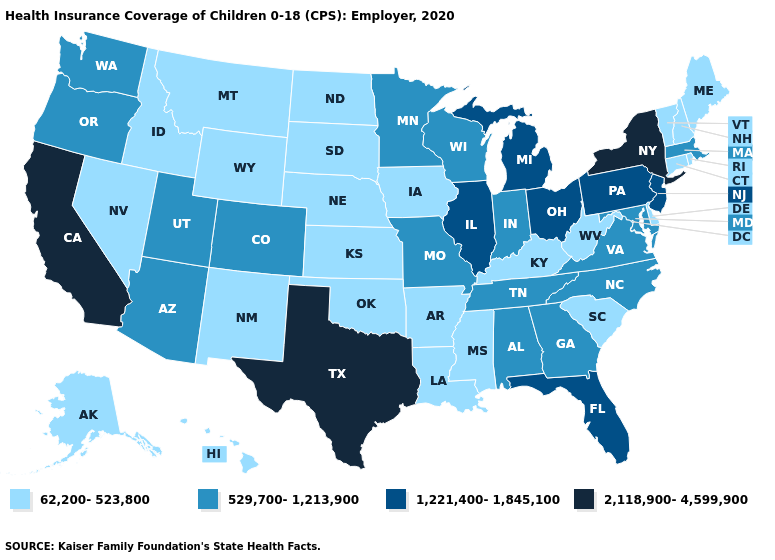What is the lowest value in the USA?
Write a very short answer. 62,200-523,800. Name the states that have a value in the range 62,200-523,800?
Short answer required. Alaska, Arkansas, Connecticut, Delaware, Hawaii, Idaho, Iowa, Kansas, Kentucky, Louisiana, Maine, Mississippi, Montana, Nebraska, Nevada, New Hampshire, New Mexico, North Dakota, Oklahoma, Rhode Island, South Carolina, South Dakota, Vermont, West Virginia, Wyoming. Does Texas have the highest value in the USA?
Answer briefly. Yes. What is the value of Wisconsin?
Keep it brief. 529,700-1,213,900. What is the highest value in the West ?
Concise answer only. 2,118,900-4,599,900. Which states have the lowest value in the USA?
Give a very brief answer. Alaska, Arkansas, Connecticut, Delaware, Hawaii, Idaho, Iowa, Kansas, Kentucky, Louisiana, Maine, Mississippi, Montana, Nebraska, Nevada, New Hampshire, New Mexico, North Dakota, Oklahoma, Rhode Island, South Carolina, South Dakota, Vermont, West Virginia, Wyoming. What is the lowest value in the South?
Write a very short answer. 62,200-523,800. Does Colorado have the lowest value in the USA?
Be succinct. No. Does North Dakota have the same value as New Hampshire?
Be succinct. Yes. Among the states that border Michigan , which have the lowest value?
Concise answer only. Indiana, Wisconsin. Does Hawaii have the lowest value in the USA?
Give a very brief answer. Yes. Among the states that border Ohio , does Michigan have the highest value?
Be succinct. Yes. Name the states that have a value in the range 529,700-1,213,900?
Short answer required. Alabama, Arizona, Colorado, Georgia, Indiana, Maryland, Massachusetts, Minnesota, Missouri, North Carolina, Oregon, Tennessee, Utah, Virginia, Washington, Wisconsin. Does Texas have the highest value in the USA?
Quick response, please. Yes. 